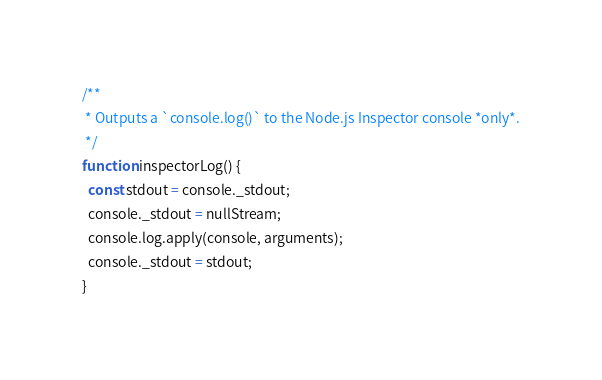<code> <loc_0><loc_0><loc_500><loc_500><_JavaScript_>
/**
 * Outputs a `console.log()` to the Node.js Inspector console *only*.
 */
function inspectorLog() {
  const stdout = console._stdout;
  console._stdout = nullStream;
  console.log.apply(console, arguments);
  console._stdout = stdout;
}
</code> 